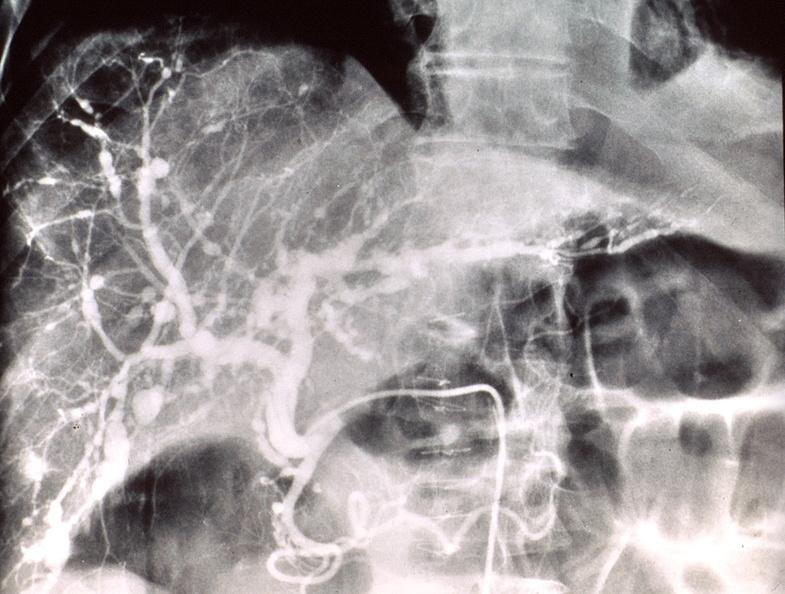what is present?
Answer the question using a single word or phrase. Hepatobiliary 